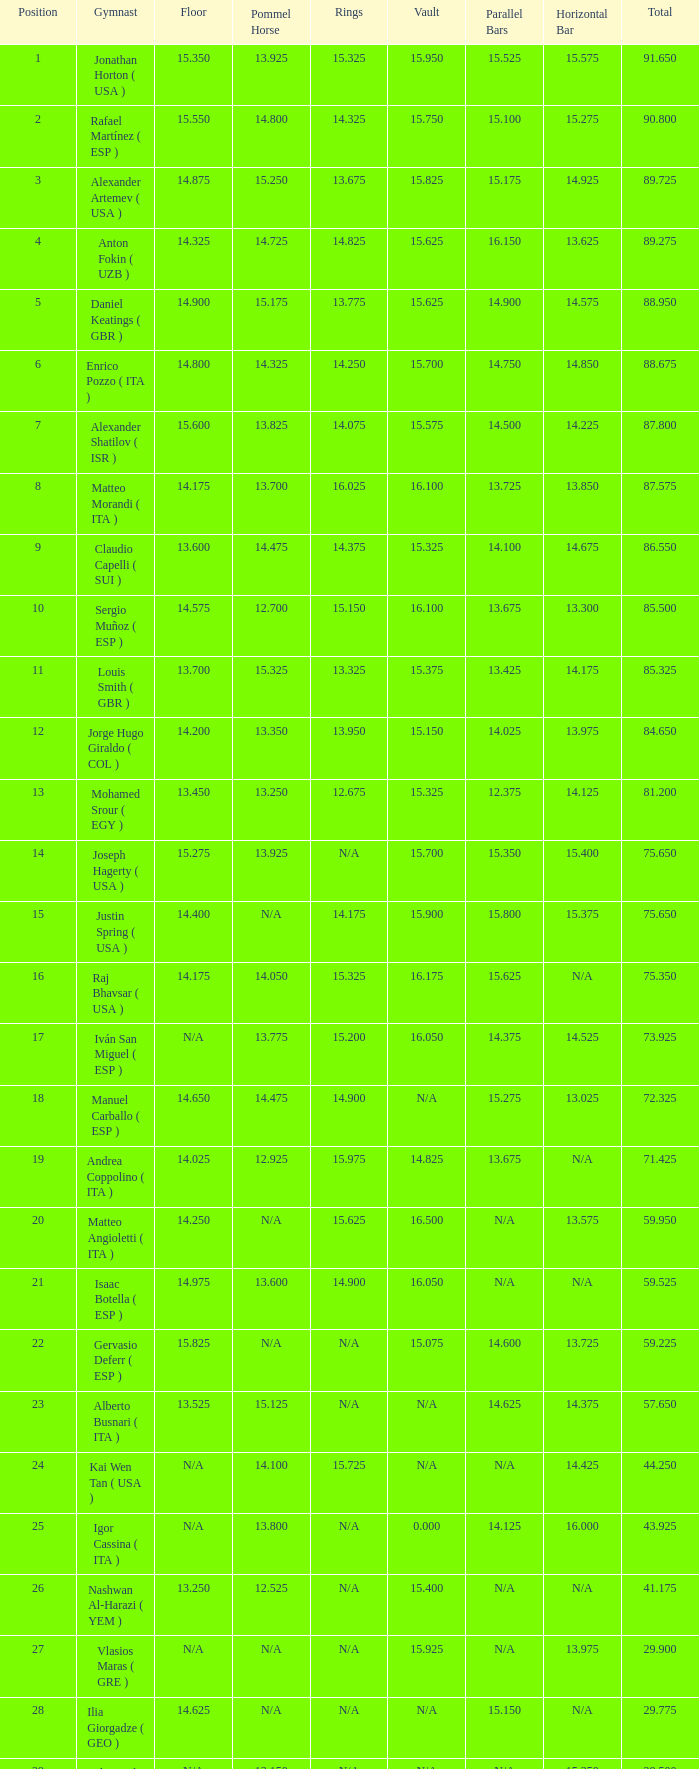150, who is the gymnast? Anton Fokin ( UZB ). 